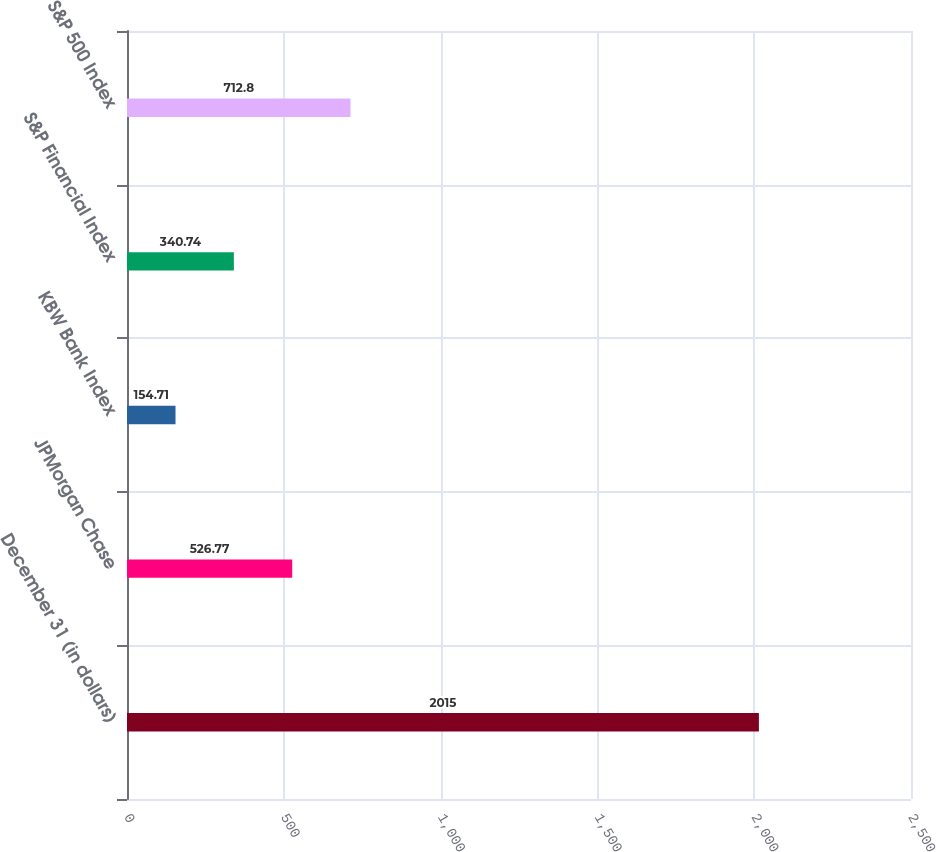Convert chart. <chart><loc_0><loc_0><loc_500><loc_500><bar_chart><fcel>December 31 (in dollars)<fcel>JPMorgan Chase<fcel>KBW Bank Index<fcel>S&P Financial Index<fcel>S&P 500 Index<nl><fcel>2015<fcel>526.77<fcel>154.71<fcel>340.74<fcel>712.8<nl></chart> 